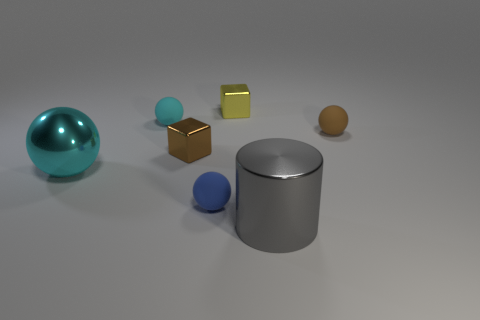There is a brown object on the right side of the big metallic thing that is on the right side of the cyan shiny object in front of the tiny cyan sphere; what is its size?
Your response must be concise. Small. What number of other objects are there of the same color as the big metal sphere?
Your answer should be compact. 1. There is a cyan thing that is the same size as the gray metallic thing; what shape is it?
Make the answer very short. Sphere. There is a brown thing left of the tiny yellow cube; what size is it?
Provide a succinct answer. Small. Does the large thing in front of the small blue thing have the same color as the block that is in front of the yellow block?
Provide a short and direct response. No. What is the material of the brown object that is to the left of the block that is behind the cyan sphere that is behind the big cyan object?
Offer a terse response. Metal. Are there any blue matte balls that have the same size as the brown metallic cube?
Your answer should be compact. Yes. What is the material of the yellow block that is the same size as the cyan matte thing?
Your response must be concise. Metal. There is a tiny metallic object on the left side of the small yellow block; what shape is it?
Give a very brief answer. Cube. Is the cyan thing that is behind the big ball made of the same material as the cube that is in front of the tiny brown matte object?
Provide a succinct answer. No. 